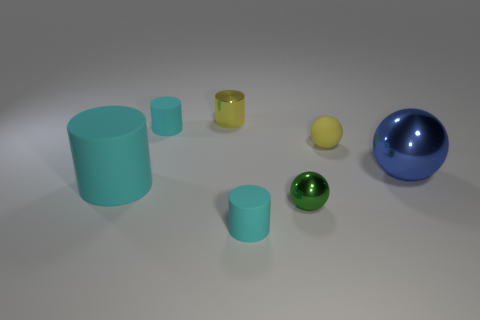There is a yellow metallic object that is the same size as the green object; what is its shape?
Give a very brief answer. Cylinder. What number of yellow objects are either large rubber cylinders or small things?
Provide a succinct answer. 2. How many brown rubber cylinders have the same size as the green ball?
Provide a short and direct response. 0. What is the shape of the matte object that is the same color as the metal cylinder?
Your answer should be very brief. Sphere. How many objects are either large blue metallic objects or balls to the right of the matte sphere?
Your response must be concise. 1. Does the metal sphere that is to the left of the yellow matte thing have the same size as the object that is on the right side of the tiny yellow sphere?
Give a very brief answer. No. How many other large blue metallic things have the same shape as the blue metallic object?
Provide a succinct answer. 0. The yellow object that is the same material as the big cylinder is what shape?
Make the answer very short. Sphere. There is a tiny cylinder on the right side of the yellow cylinder left of the ball on the right side of the rubber ball; what is its material?
Keep it short and to the point. Rubber. Do the yellow cylinder and the blue sphere on the right side of the yellow metallic thing have the same size?
Your answer should be very brief. No. 